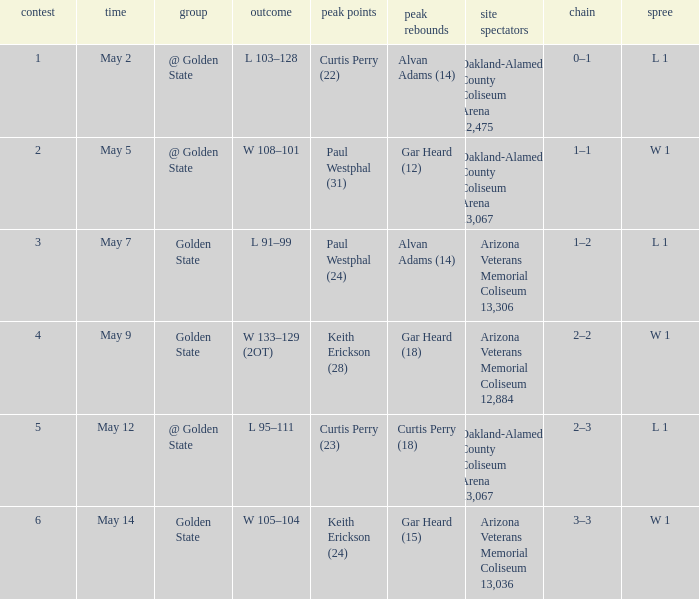What was their winning or losing streak count on may 9? W 1. 